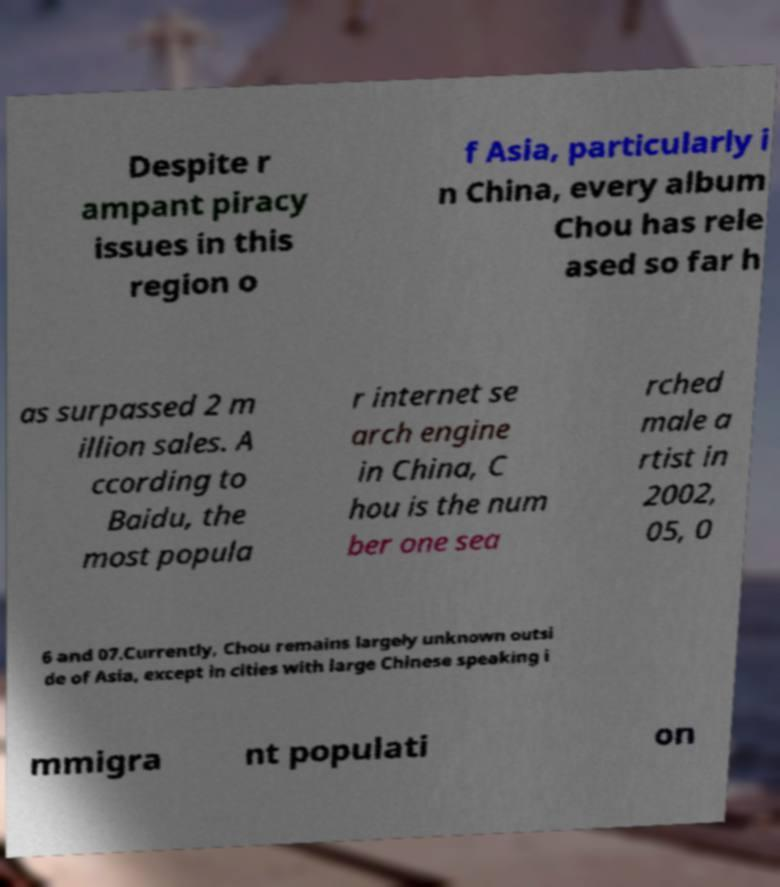There's text embedded in this image that I need extracted. Can you transcribe it verbatim? Despite r ampant piracy issues in this region o f Asia, particularly i n China, every album Chou has rele ased so far h as surpassed 2 m illion sales. A ccording to Baidu, the most popula r internet se arch engine in China, C hou is the num ber one sea rched male a rtist in 2002, 05, 0 6 and 07.Currently, Chou remains largely unknown outsi de of Asia, except in cities with large Chinese speaking i mmigra nt populati on 